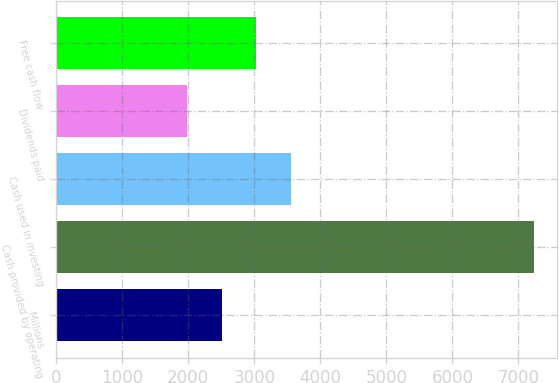Convert chart. <chart><loc_0><loc_0><loc_500><loc_500><bar_chart><fcel>Millions<fcel>Cash provided by operating<fcel>Cash used in investing<fcel>Dividends paid<fcel>Free cash flow<nl><fcel>2506.8<fcel>7230<fcel>3556.4<fcel>1982<fcel>3031.6<nl></chart> 